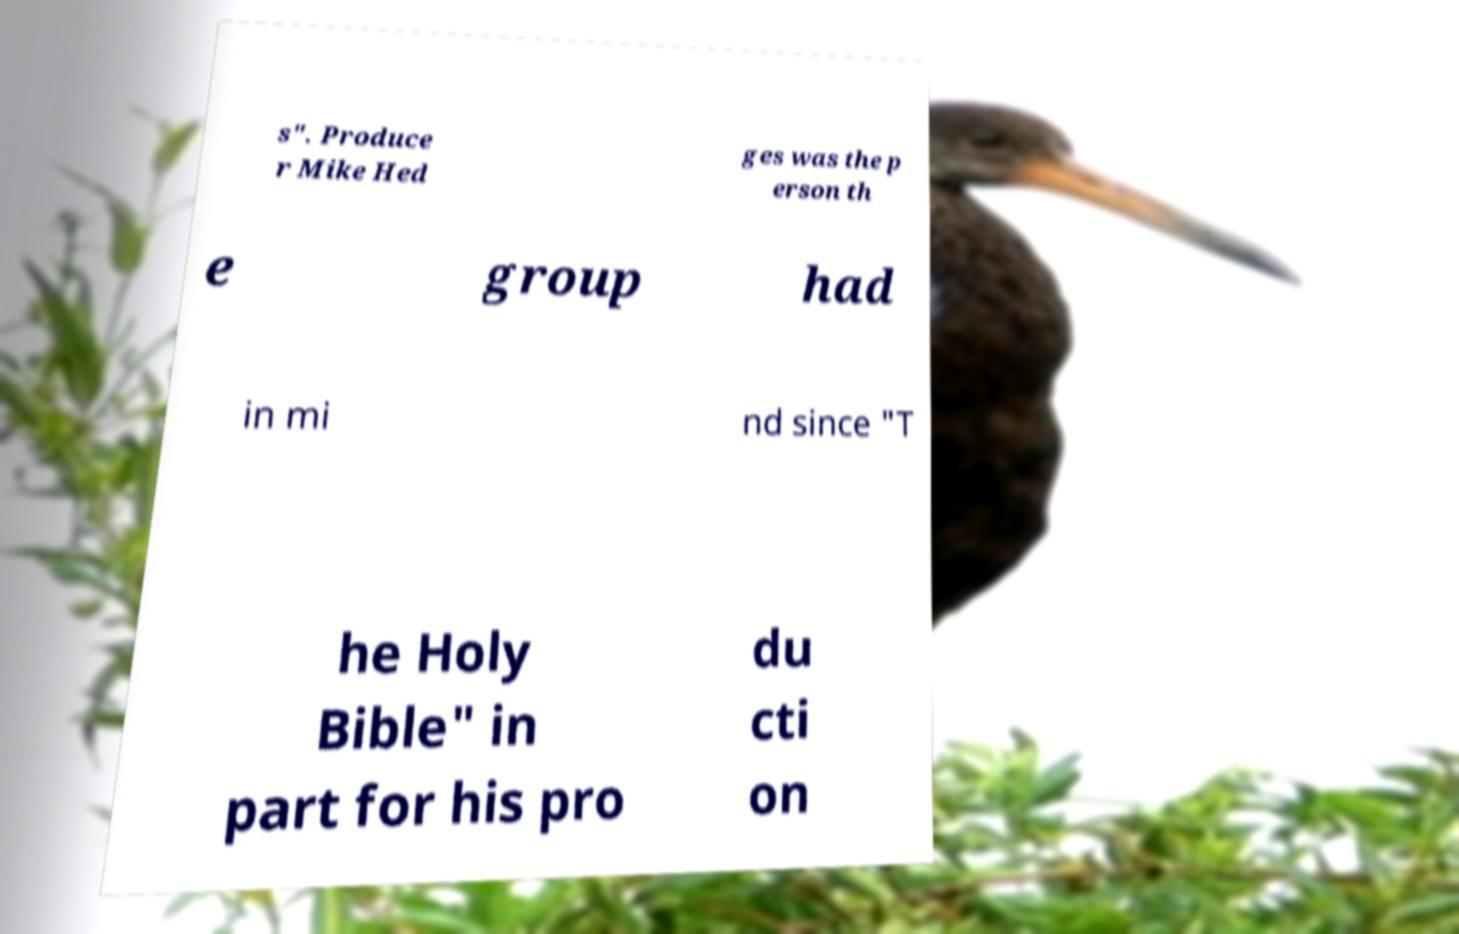There's text embedded in this image that I need extracted. Can you transcribe it verbatim? s". Produce r Mike Hed ges was the p erson th e group had in mi nd since "T he Holy Bible" in part for his pro du cti on 